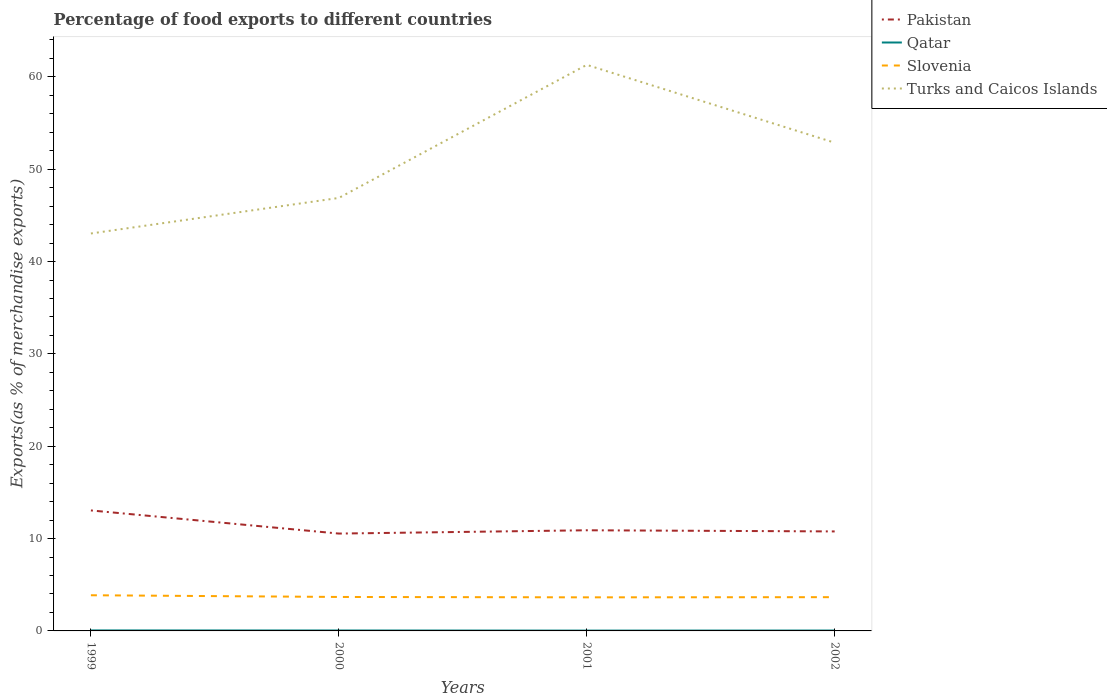Does the line corresponding to Turks and Caicos Islands intersect with the line corresponding to Slovenia?
Your answer should be very brief. No. Is the number of lines equal to the number of legend labels?
Offer a terse response. Yes. Across all years, what is the maximum percentage of exports to different countries in Turks and Caicos Islands?
Ensure brevity in your answer.  43.04. In which year was the percentage of exports to different countries in Pakistan maximum?
Your response must be concise. 2000. What is the total percentage of exports to different countries in Qatar in the graph?
Give a very brief answer. 0.01. What is the difference between the highest and the second highest percentage of exports to different countries in Slovenia?
Provide a succinct answer. 0.23. Is the percentage of exports to different countries in Qatar strictly greater than the percentage of exports to different countries in Pakistan over the years?
Ensure brevity in your answer.  Yes. How many years are there in the graph?
Your answer should be very brief. 4. What is the difference between two consecutive major ticks on the Y-axis?
Your answer should be very brief. 10. Are the values on the major ticks of Y-axis written in scientific E-notation?
Make the answer very short. No. Does the graph contain any zero values?
Your answer should be compact. No. Where does the legend appear in the graph?
Give a very brief answer. Top right. How many legend labels are there?
Give a very brief answer. 4. How are the legend labels stacked?
Offer a terse response. Vertical. What is the title of the graph?
Keep it short and to the point. Percentage of food exports to different countries. Does "China" appear as one of the legend labels in the graph?
Your answer should be very brief. No. What is the label or title of the X-axis?
Provide a short and direct response. Years. What is the label or title of the Y-axis?
Offer a very short reply. Exports(as % of merchandise exports). What is the Exports(as % of merchandise exports) in Pakistan in 1999?
Your answer should be very brief. 13.05. What is the Exports(as % of merchandise exports) of Qatar in 1999?
Keep it short and to the point. 0.05. What is the Exports(as % of merchandise exports) in Slovenia in 1999?
Your answer should be very brief. 3.86. What is the Exports(as % of merchandise exports) in Turks and Caicos Islands in 1999?
Provide a short and direct response. 43.04. What is the Exports(as % of merchandise exports) in Pakistan in 2000?
Your answer should be compact. 10.54. What is the Exports(as % of merchandise exports) of Qatar in 2000?
Provide a succinct answer. 0.05. What is the Exports(as % of merchandise exports) in Slovenia in 2000?
Give a very brief answer. 3.68. What is the Exports(as % of merchandise exports) in Turks and Caicos Islands in 2000?
Offer a terse response. 46.89. What is the Exports(as % of merchandise exports) in Pakistan in 2001?
Give a very brief answer. 10.9. What is the Exports(as % of merchandise exports) of Qatar in 2001?
Make the answer very short. 0.04. What is the Exports(as % of merchandise exports) of Slovenia in 2001?
Your answer should be compact. 3.64. What is the Exports(as % of merchandise exports) in Turks and Caicos Islands in 2001?
Make the answer very short. 61.3. What is the Exports(as % of merchandise exports) of Pakistan in 2002?
Offer a terse response. 10.77. What is the Exports(as % of merchandise exports) of Qatar in 2002?
Your answer should be compact. 0.04. What is the Exports(as % of merchandise exports) of Slovenia in 2002?
Give a very brief answer. 3.66. What is the Exports(as % of merchandise exports) in Turks and Caicos Islands in 2002?
Keep it short and to the point. 52.87. Across all years, what is the maximum Exports(as % of merchandise exports) in Pakistan?
Provide a succinct answer. 13.05. Across all years, what is the maximum Exports(as % of merchandise exports) in Qatar?
Your response must be concise. 0.05. Across all years, what is the maximum Exports(as % of merchandise exports) in Slovenia?
Offer a very short reply. 3.86. Across all years, what is the maximum Exports(as % of merchandise exports) of Turks and Caicos Islands?
Ensure brevity in your answer.  61.3. Across all years, what is the minimum Exports(as % of merchandise exports) in Pakistan?
Ensure brevity in your answer.  10.54. Across all years, what is the minimum Exports(as % of merchandise exports) of Qatar?
Provide a short and direct response. 0.04. Across all years, what is the minimum Exports(as % of merchandise exports) of Slovenia?
Your answer should be very brief. 3.64. Across all years, what is the minimum Exports(as % of merchandise exports) of Turks and Caicos Islands?
Your answer should be very brief. 43.04. What is the total Exports(as % of merchandise exports) of Pakistan in the graph?
Give a very brief answer. 45.27. What is the total Exports(as % of merchandise exports) in Qatar in the graph?
Offer a very short reply. 0.18. What is the total Exports(as % of merchandise exports) in Slovenia in the graph?
Your answer should be compact. 14.83. What is the total Exports(as % of merchandise exports) of Turks and Caicos Islands in the graph?
Give a very brief answer. 204.1. What is the difference between the Exports(as % of merchandise exports) of Pakistan in 1999 and that in 2000?
Ensure brevity in your answer.  2.51. What is the difference between the Exports(as % of merchandise exports) in Qatar in 1999 and that in 2000?
Give a very brief answer. 0.01. What is the difference between the Exports(as % of merchandise exports) in Slovenia in 1999 and that in 2000?
Ensure brevity in your answer.  0.19. What is the difference between the Exports(as % of merchandise exports) of Turks and Caicos Islands in 1999 and that in 2000?
Your answer should be compact. -3.85. What is the difference between the Exports(as % of merchandise exports) in Pakistan in 1999 and that in 2001?
Your response must be concise. 2.15. What is the difference between the Exports(as % of merchandise exports) in Qatar in 1999 and that in 2001?
Your answer should be compact. 0.02. What is the difference between the Exports(as % of merchandise exports) in Slovenia in 1999 and that in 2001?
Offer a very short reply. 0.23. What is the difference between the Exports(as % of merchandise exports) of Turks and Caicos Islands in 1999 and that in 2001?
Ensure brevity in your answer.  -18.26. What is the difference between the Exports(as % of merchandise exports) in Pakistan in 1999 and that in 2002?
Provide a succinct answer. 2.27. What is the difference between the Exports(as % of merchandise exports) of Qatar in 1999 and that in 2002?
Offer a terse response. 0.01. What is the difference between the Exports(as % of merchandise exports) of Slovenia in 1999 and that in 2002?
Your response must be concise. 0.21. What is the difference between the Exports(as % of merchandise exports) of Turks and Caicos Islands in 1999 and that in 2002?
Make the answer very short. -9.83. What is the difference between the Exports(as % of merchandise exports) of Pakistan in 2000 and that in 2001?
Offer a very short reply. -0.36. What is the difference between the Exports(as % of merchandise exports) of Qatar in 2000 and that in 2001?
Offer a terse response. 0.01. What is the difference between the Exports(as % of merchandise exports) of Slovenia in 2000 and that in 2001?
Your answer should be compact. 0.04. What is the difference between the Exports(as % of merchandise exports) of Turks and Caicos Islands in 2000 and that in 2001?
Your response must be concise. -14.41. What is the difference between the Exports(as % of merchandise exports) of Pakistan in 2000 and that in 2002?
Give a very brief answer. -0.23. What is the difference between the Exports(as % of merchandise exports) in Qatar in 2000 and that in 2002?
Make the answer very short. 0.01. What is the difference between the Exports(as % of merchandise exports) of Slovenia in 2000 and that in 2002?
Your answer should be very brief. 0.02. What is the difference between the Exports(as % of merchandise exports) in Turks and Caicos Islands in 2000 and that in 2002?
Provide a succinct answer. -5.98. What is the difference between the Exports(as % of merchandise exports) in Pakistan in 2001 and that in 2002?
Give a very brief answer. 0.13. What is the difference between the Exports(as % of merchandise exports) in Qatar in 2001 and that in 2002?
Offer a very short reply. -0.01. What is the difference between the Exports(as % of merchandise exports) of Slovenia in 2001 and that in 2002?
Provide a short and direct response. -0.02. What is the difference between the Exports(as % of merchandise exports) of Turks and Caicos Islands in 2001 and that in 2002?
Offer a very short reply. 8.43. What is the difference between the Exports(as % of merchandise exports) in Pakistan in 1999 and the Exports(as % of merchandise exports) in Qatar in 2000?
Ensure brevity in your answer.  13. What is the difference between the Exports(as % of merchandise exports) in Pakistan in 1999 and the Exports(as % of merchandise exports) in Slovenia in 2000?
Make the answer very short. 9.37. What is the difference between the Exports(as % of merchandise exports) of Pakistan in 1999 and the Exports(as % of merchandise exports) of Turks and Caicos Islands in 2000?
Give a very brief answer. -33.84. What is the difference between the Exports(as % of merchandise exports) in Qatar in 1999 and the Exports(as % of merchandise exports) in Slovenia in 2000?
Your response must be concise. -3.62. What is the difference between the Exports(as % of merchandise exports) of Qatar in 1999 and the Exports(as % of merchandise exports) of Turks and Caicos Islands in 2000?
Provide a short and direct response. -46.84. What is the difference between the Exports(as % of merchandise exports) of Slovenia in 1999 and the Exports(as % of merchandise exports) of Turks and Caicos Islands in 2000?
Ensure brevity in your answer.  -43.03. What is the difference between the Exports(as % of merchandise exports) of Pakistan in 1999 and the Exports(as % of merchandise exports) of Qatar in 2001?
Provide a succinct answer. 13.01. What is the difference between the Exports(as % of merchandise exports) of Pakistan in 1999 and the Exports(as % of merchandise exports) of Slovenia in 2001?
Make the answer very short. 9.41. What is the difference between the Exports(as % of merchandise exports) in Pakistan in 1999 and the Exports(as % of merchandise exports) in Turks and Caicos Islands in 2001?
Provide a succinct answer. -48.25. What is the difference between the Exports(as % of merchandise exports) in Qatar in 1999 and the Exports(as % of merchandise exports) in Slovenia in 2001?
Provide a short and direct response. -3.58. What is the difference between the Exports(as % of merchandise exports) in Qatar in 1999 and the Exports(as % of merchandise exports) in Turks and Caicos Islands in 2001?
Provide a short and direct response. -61.25. What is the difference between the Exports(as % of merchandise exports) in Slovenia in 1999 and the Exports(as % of merchandise exports) in Turks and Caicos Islands in 2001?
Offer a very short reply. -57.44. What is the difference between the Exports(as % of merchandise exports) of Pakistan in 1999 and the Exports(as % of merchandise exports) of Qatar in 2002?
Offer a very short reply. 13.01. What is the difference between the Exports(as % of merchandise exports) of Pakistan in 1999 and the Exports(as % of merchandise exports) of Slovenia in 2002?
Offer a terse response. 9.39. What is the difference between the Exports(as % of merchandise exports) in Pakistan in 1999 and the Exports(as % of merchandise exports) in Turks and Caicos Islands in 2002?
Offer a very short reply. -39.82. What is the difference between the Exports(as % of merchandise exports) in Qatar in 1999 and the Exports(as % of merchandise exports) in Slovenia in 2002?
Your response must be concise. -3.6. What is the difference between the Exports(as % of merchandise exports) in Qatar in 1999 and the Exports(as % of merchandise exports) in Turks and Caicos Islands in 2002?
Keep it short and to the point. -52.82. What is the difference between the Exports(as % of merchandise exports) in Slovenia in 1999 and the Exports(as % of merchandise exports) in Turks and Caicos Islands in 2002?
Give a very brief answer. -49.01. What is the difference between the Exports(as % of merchandise exports) of Pakistan in 2000 and the Exports(as % of merchandise exports) of Qatar in 2001?
Your response must be concise. 10.51. What is the difference between the Exports(as % of merchandise exports) in Pakistan in 2000 and the Exports(as % of merchandise exports) in Slovenia in 2001?
Ensure brevity in your answer.  6.91. What is the difference between the Exports(as % of merchandise exports) of Pakistan in 2000 and the Exports(as % of merchandise exports) of Turks and Caicos Islands in 2001?
Make the answer very short. -50.76. What is the difference between the Exports(as % of merchandise exports) of Qatar in 2000 and the Exports(as % of merchandise exports) of Slovenia in 2001?
Ensure brevity in your answer.  -3.59. What is the difference between the Exports(as % of merchandise exports) in Qatar in 2000 and the Exports(as % of merchandise exports) in Turks and Caicos Islands in 2001?
Make the answer very short. -61.25. What is the difference between the Exports(as % of merchandise exports) of Slovenia in 2000 and the Exports(as % of merchandise exports) of Turks and Caicos Islands in 2001?
Ensure brevity in your answer.  -57.62. What is the difference between the Exports(as % of merchandise exports) of Pakistan in 2000 and the Exports(as % of merchandise exports) of Qatar in 2002?
Offer a very short reply. 10.5. What is the difference between the Exports(as % of merchandise exports) of Pakistan in 2000 and the Exports(as % of merchandise exports) of Slovenia in 2002?
Ensure brevity in your answer.  6.89. What is the difference between the Exports(as % of merchandise exports) of Pakistan in 2000 and the Exports(as % of merchandise exports) of Turks and Caicos Islands in 2002?
Your answer should be compact. -42.33. What is the difference between the Exports(as % of merchandise exports) of Qatar in 2000 and the Exports(as % of merchandise exports) of Slovenia in 2002?
Your answer should be compact. -3.61. What is the difference between the Exports(as % of merchandise exports) in Qatar in 2000 and the Exports(as % of merchandise exports) in Turks and Caicos Islands in 2002?
Provide a succinct answer. -52.82. What is the difference between the Exports(as % of merchandise exports) of Slovenia in 2000 and the Exports(as % of merchandise exports) of Turks and Caicos Islands in 2002?
Provide a succinct answer. -49.19. What is the difference between the Exports(as % of merchandise exports) of Pakistan in 2001 and the Exports(as % of merchandise exports) of Qatar in 2002?
Make the answer very short. 10.86. What is the difference between the Exports(as % of merchandise exports) of Pakistan in 2001 and the Exports(as % of merchandise exports) of Slovenia in 2002?
Your answer should be very brief. 7.24. What is the difference between the Exports(as % of merchandise exports) of Pakistan in 2001 and the Exports(as % of merchandise exports) of Turks and Caicos Islands in 2002?
Your answer should be compact. -41.97. What is the difference between the Exports(as % of merchandise exports) of Qatar in 2001 and the Exports(as % of merchandise exports) of Slovenia in 2002?
Your response must be concise. -3.62. What is the difference between the Exports(as % of merchandise exports) of Qatar in 2001 and the Exports(as % of merchandise exports) of Turks and Caicos Islands in 2002?
Ensure brevity in your answer.  -52.84. What is the difference between the Exports(as % of merchandise exports) in Slovenia in 2001 and the Exports(as % of merchandise exports) in Turks and Caicos Islands in 2002?
Ensure brevity in your answer.  -49.23. What is the average Exports(as % of merchandise exports) of Pakistan per year?
Your response must be concise. 11.32. What is the average Exports(as % of merchandise exports) in Qatar per year?
Your answer should be very brief. 0.04. What is the average Exports(as % of merchandise exports) of Slovenia per year?
Offer a very short reply. 3.71. What is the average Exports(as % of merchandise exports) of Turks and Caicos Islands per year?
Your response must be concise. 51.03. In the year 1999, what is the difference between the Exports(as % of merchandise exports) in Pakistan and Exports(as % of merchandise exports) in Qatar?
Provide a short and direct response. 12.99. In the year 1999, what is the difference between the Exports(as % of merchandise exports) of Pakistan and Exports(as % of merchandise exports) of Slovenia?
Keep it short and to the point. 9.19. In the year 1999, what is the difference between the Exports(as % of merchandise exports) in Pakistan and Exports(as % of merchandise exports) in Turks and Caicos Islands?
Your answer should be very brief. -29.99. In the year 1999, what is the difference between the Exports(as % of merchandise exports) in Qatar and Exports(as % of merchandise exports) in Slovenia?
Your answer should be very brief. -3.81. In the year 1999, what is the difference between the Exports(as % of merchandise exports) of Qatar and Exports(as % of merchandise exports) of Turks and Caicos Islands?
Your answer should be compact. -42.99. In the year 1999, what is the difference between the Exports(as % of merchandise exports) in Slovenia and Exports(as % of merchandise exports) in Turks and Caicos Islands?
Your answer should be compact. -39.18. In the year 2000, what is the difference between the Exports(as % of merchandise exports) of Pakistan and Exports(as % of merchandise exports) of Qatar?
Give a very brief answer. 10.5. In the year 2000, what is the difference between the Exports(as % of merchandise exports) of Pakistan and Exports(as % of merchandise exports) of Slovenia?
Offer a very short reply. 6.86. In the year 2000, what is the difference between the Exports(as % of merchandise exports) in Pakistan and Exports(as % of merchandise exports) in Turks and Caicos Islands?
Offer a very short reply. -36.35. In the year 2000, what is the difference between the Exports(as % of merchandise exports) in Qatar and Exports(as % of merchandise exports) in Slovenia?
Keep it short and to the point. -3.63. In the year 2000, what is the difference between the Exports(as % of merchandise exports) in Qatar and Exports(as % of merchandise exports) in Turks and Caicos Islands?
Keep it short and to the point. -46.84. In the year 2000, what is the difference between the Exports(as % of merchandise exports) in Slovenia and Exports(as % of merchandise exports) in Turks and Caicos Islands?
Your response must be concise. -43.21. In the year 2001, what is the difference between the Exports(as % of merchandise exports) of Pakistan and Exports(as % of merchandise exports) of Qatar?
Make the answer very short. 10.86. In the year 2001, what is the difference between the Exports(as % of merchandise exports) in Pakistan and Exports(as % of merchandise exports) in Slovenia?
Offer a very short reply. 7.26. In the year 2001, what is the difference between the Exports(as % of merchandise exports) in Pakistan and Exports(as % of merchandise exports) in Turks and Caicos Islands?
Give a very brief answer. -50.4. In the year 2001, what is the difference between the Exports(as % of merchandise exports) in Qatar and Exports(as % of merchandise exports) in Slovenia?
Provide a short and direct response. -3.6. In the year 2001, what is the difference between the Exports(as % of merchandise exports) in Qatar and Exports(as % of merchandise exports) in Turks and Caicos Islands?
Make the answer very short. -61.27. In the year 2001, what is the difference between the Exports(as % of merchandise exports) of Slovenia and Exports(as % of merchandise exports) of Turks and Caicos Islands?
Provide a succinct answer. -57.66. In the year 2002, what is the difference between the Exports(as % of merchandise exports) in Pakistan and Exports(as % of merchandise exports) in Qatar?
Make the answer very short. 10.73. In the year 2002, what is the difference between the Exports(as % of merchandise exports) in Pakistan and Exports(as % of merchandise exports) in Slovenia?
Offer a terse response. 7.12. In the year 2002, what is the difference between the Exports(as % of merchandise exports) of Pakistan and Exports(as % of merchandise exports) of Turks and Caicos Islands?
Provide a succinct answer. -42.1. In the year 2002, what is the difference between the Exports(as % of merchandise exports) of Qatar and Exports(as % of merchandise exports) of Slovenia?
Keep it short and to the point. -3.61. In the year 2002, what is the difference between the Exports(as % of merchandise exports) of Qatar and Exports(as % of merchandise exports) of Turks and Caicos Islands?
Make the answer very short. -52.83. In the year 2002, what is the difference between the Exports(as % of merchandise exports) of Slovenia and Exports(as % of merchandise exports) of Turks and Caicos Islands?
Your answer should be very brief. -49.21. What is the ratio of the Exports(as % of merchandise exports) in Pakistan in 1999 to that in 2000?
Ensure brevity in your answer.  1.24. What is the ratio of the Exports(as % of merchandise exports) of Qatar in 1999 to that in 2000?
Give a very brief answer. 1.13. What is the ratio of the Exports(as % of merchandise exports) of Slovenia in 1999 to that in 2000?
Give a very brief answer. 1.05. What is the ratio of the Exports(as % of merchandise exports) in Turks and Caicos Islands in 1999 to that in 2000?
Your response must be concise. 0.92. What is the ratio of the Exports(as % of merchandise exports) in Pakistan in 1999 to that in 2001?
Make the answer very short. 1.2. What is the ratio of the Exports(as % of merchandise exports) of Qatar in 1999 to that in 2001?
Offer a very short reply. 1.52. What is the ratio of the Exports(as % of merchandise exports) in Slovenia in 1999 to that in 2001?
Provide a succinct answer. 1.06. What is the ratio of the Exports(as % of merchandise exports) of Turks and Caicos Islands in 1999 to that in 2001?
Your answer should be compact. 0.7. What is the ratio of the Exports(as % of merchandise exports) in Pakistan in 1999 to that in 2002?
Your response must be concise. 1.21. What is the ratio of the Exports(as % of merchandise exports) in Qatar in 1999 to that in 2002?
Make the answer very short. 1.27. What is the ratio of the Exports(as % of merchandise exports) in Slovenia in 1999 to that in 2002?
Ensure brevity in your answer.  1.06. What is the ratio of the Exports(as % of merchandise exports) in Turks and Caicos Islands in 1999 to that in 2002?
Offer a terse response. 0.81. What is the ratio of the Exports(as % of merchandise exports) of Pakistan in 2000 to that in 2001?
Your answer should be compact. 0.97. What is the ratio of the Exports(as % of merchandise exports) in Qatar in 2000 to that in 2001?
Your answer should be very brief. 1.35. What is the ratio of the Exports(as % of merchandise exports) in Slovenia in 2000 to that in 2001?
Offer a very short reply. 1.01. What is the ratio of the Exports(as % of merchandise exports) in Turks and Caicos Islands in 2000 to that in 2001?
Provide a succinct answer. 0.76. What is the ratio of the Exports(as % of merchandise exports) of Pakistan in 2000 to that in 2002?
Give a very brief answer. 0.98. What is the ratio of the Exports(as % of merchandise exports) in Qatar in 2000 to that in 2002?
Your answer should be very brief. 1.13. What is the ratio of the Exports(as % of merchandise exports) in Slovenia in 2000 to that in 2002?
Your answer should be very brief. 1.01. What is the ratio of the Exports(as % of merchandise exports) of Turks and Caicos Islands in 2000 to that in 2002?
Your answer should be very brief. 0.89. What is the ratio of the Exports(as % of merchandise exports) in Pakistan in 2001 to that in 2002?
Your response must be concise. 1.01. What is the ratio of the Exports(as % of merchandise exports) in Qatar in 2001 to that in 2002?
Ensure brevity in your answer.  0.84. What is the ratio of the Exports(as % of merchandise exports) in Turks and Caicos Islands in 2001 to that in 2002?
Your answer should be very brief. 1.16. What is the difference between the highest and the second highest Exports(as % of merchandise exports) of Pakistan?
Your answer should be very brief. 2.15. What is the difference between the highest and the second highest Exports(as % of merchandise exports) of Qatar?
Provide a succinct answer. 0.01. What is the difference between the highest and the second highest Exports(as % of merchandise exports) of Slovenia?
Provide a succinct answer. 0.19. What is the difference between the highest and the second highest Exports(as % of merchandise exports) of Turks and Caicos Islands?
Make the answer very short. 8.43. What is the difference between the highest and the lowest Exports(as % of merchandise exports) of Pakistan?
Offer a very short reply. 2.51. What is the difference between the highest and the lowest Exports(as % of merchandise exports) in Qatar?
Make the answer very short. 0.02. What is the difference between the highest and the lowest Exports(as % of merchandise exports) of Slovenia?
Give a very brief answer. 0.23. What is the difference between the highest and the lowest Exports(as % of merchandise exports) in Turks and Caicos Islands?
Your answer should be compact. 18.26. 